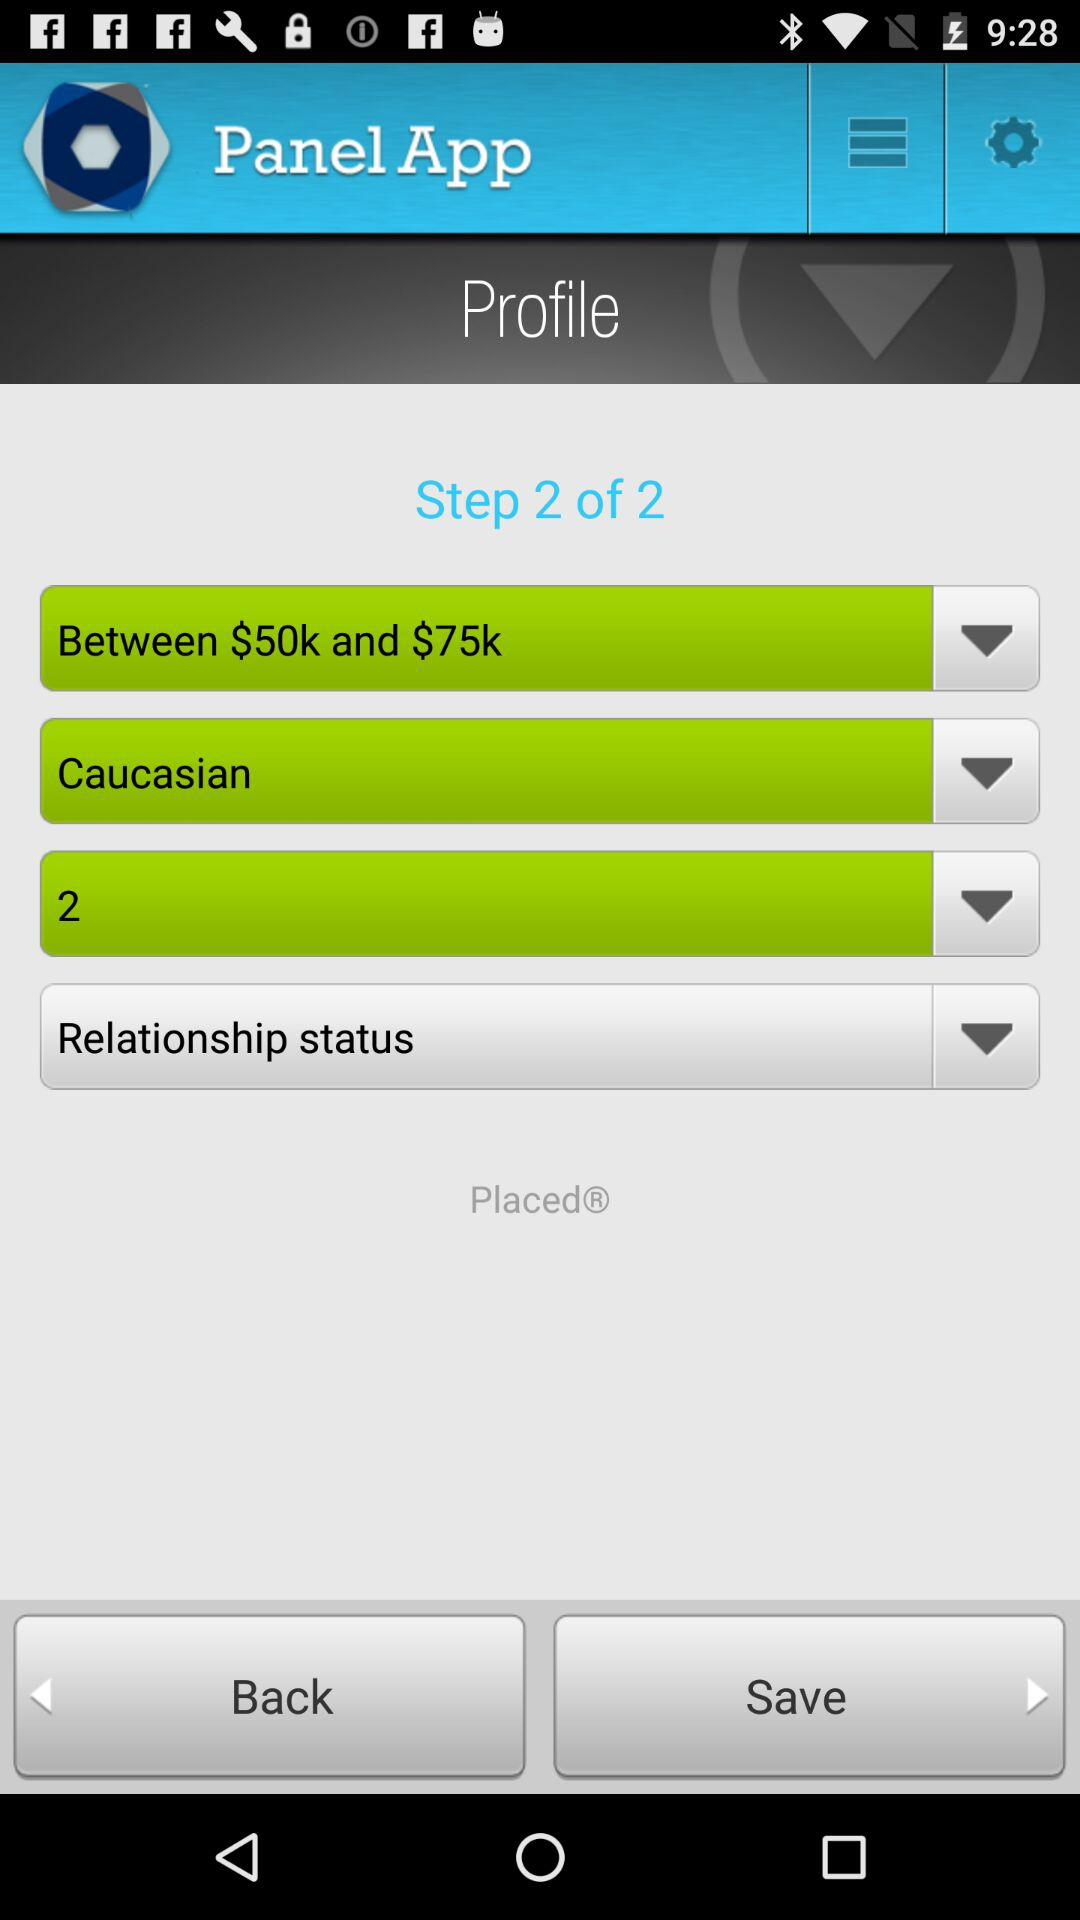What is the currency for the prices? The currency is $. 